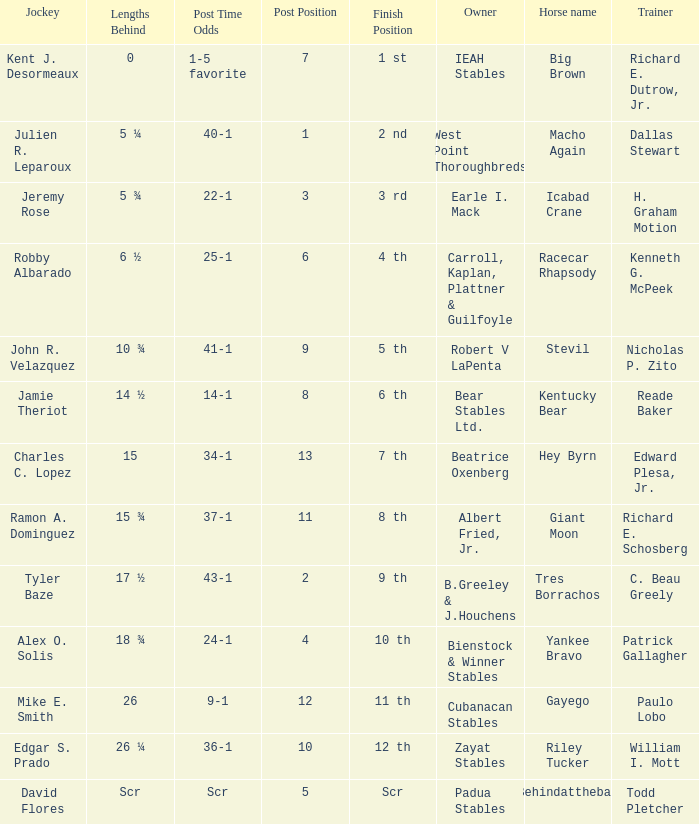Who is the owner of Icabad Crane? Earle I. Mack. 